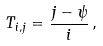<formula> <loc_0><loc_0><loc_500><loc_500>T _ { i , j } = \frac { j - \psi } { i } \, ,</formula> 